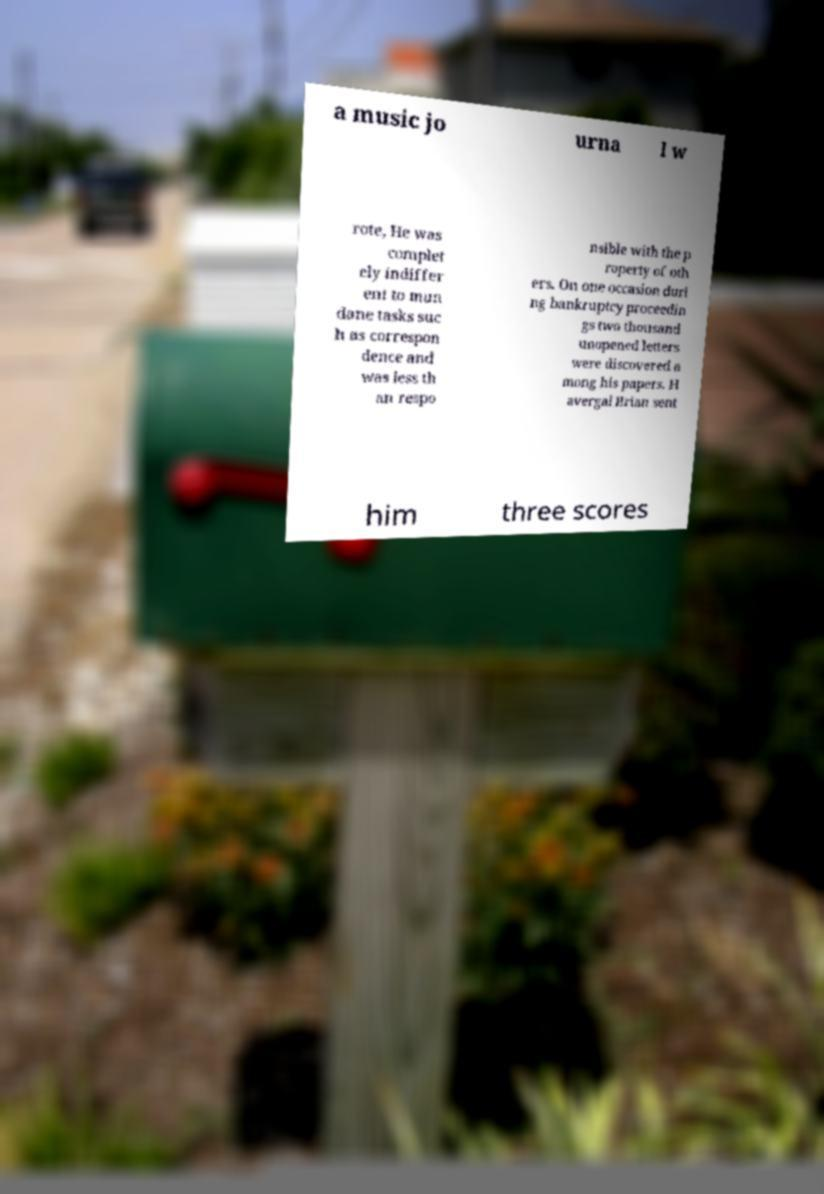Please read and relay the text visible in this image. What does it say? a music jo urna l w rote, He was complet ely indiffer ent to mun dane tasks suc h as correspon dence and was less th an respo nsible with the p roperty of oth ers. On one occasion duri ng bankruptcy proceedin gs two thousand unopened letters were discovered a mong his papers. H avergal Brian sent him three scores 